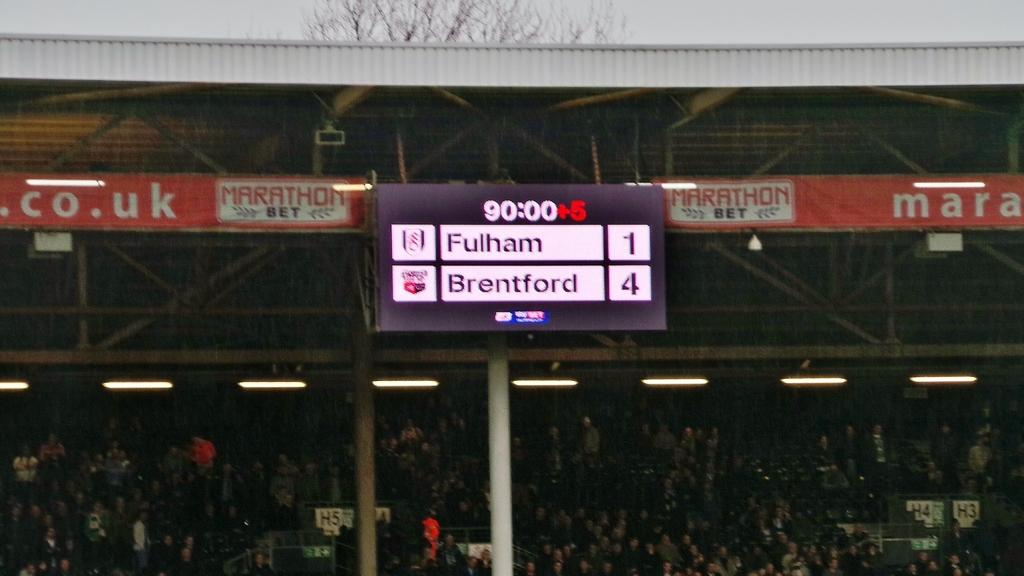How many people are in the group visible in the image? There is a group of persons in the image, but the exact number cannot be determined from the provided facts. What can be seen illuminating the area in the image? There are lights in the image. What structures are present in the image that support the lights? There are poles in the image. What is covering the area above the group of persons in the image? There is a roof visible in the image. What type of signage is present in the image with text? There are banners with text and a scoreboard with text in the image. What type of bead is used to decorate the stomach of the person in the image? There is no mention of any person's stomach or beads in the provided facts, so this question cannot be answered. 